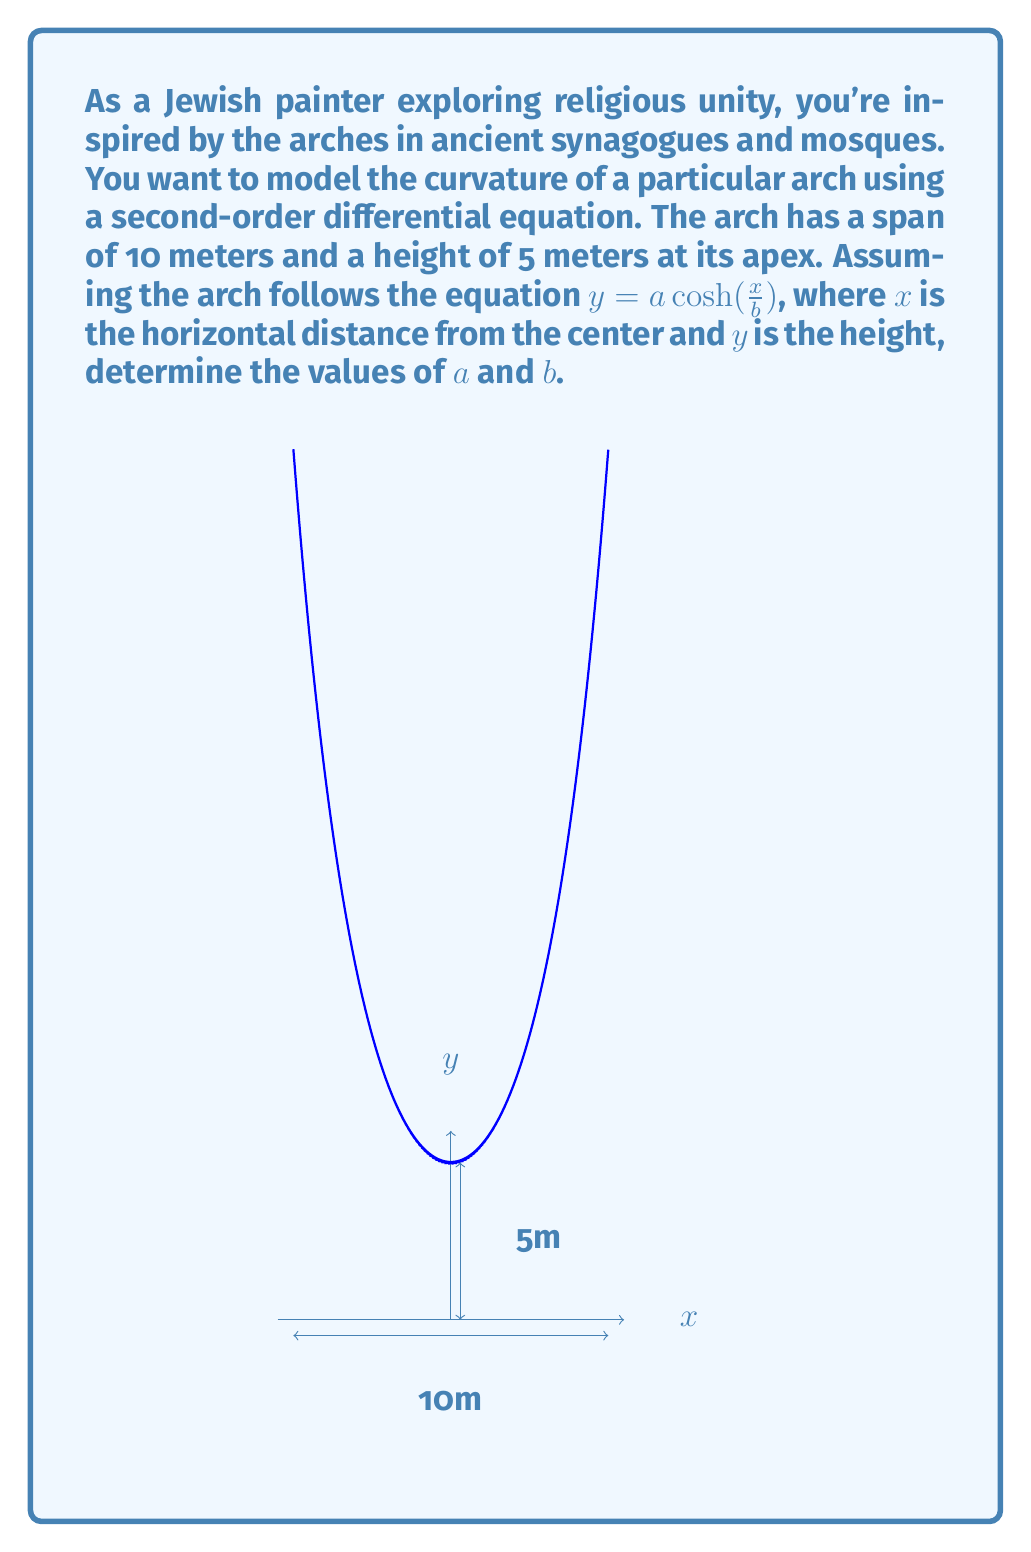What is the answer to this math problem? Let's approach this step-by-step:

1) The general equation for the arch is $y = a \cosh(\frac{x}{b})$.

2) We know two points on this curve:
   At the center: $(0, 5)$
   At the edge: $(5, 0)$

3) Using the center point $(0, 5)$:
   $5 = a \cosh(0)$
   $5 = a \cdot 1$
   $a = 5$

4) Now, using the edge point $(5, 0)$:
   $0 = 5 \cosh(\frac{5}{b})$

5) This is impossible as $\cosh$ is always positive. The arch doesn't actually reach $y=0$. Instead, let's assume it reaches a very small height, say $0.01$ meters:
   $0.01 = 5 \cosh(\frac{5}{b})$

6) Solving for $b$:
   $\frac{0.01}{5} = \cosh(\frac{5}{b})$
   $0.002 = \cosh(\frac{5}{b})$
   $\text{arccosh}(0.002) = \frac{5}{b}$
   $b = \frac{5}{\text{arccosh}(0.002)} \approx 2.0878$

7) Therefore, the equation of the arch is:
   $y = 5 \cosh(\frac{x}{2.0878})$

8) To verify this is a solution to a second-order differential equation, we can differentiate twice:
   $y' = \frac{5}{2.0878} \sinh(\frac{x}{2.0878})$
   $y'' = \frac{5}{(2.0878)^2} \cosh(\frac{x}{2.0878}) = \frac{y}{(2.0878)^2}$

9) This gives us the second-order differential equation:
   $y'' - \frac{1}{(2.0878)^2}y = 0$
Answer: $a = 5$, $b \approx 2.0878$ 